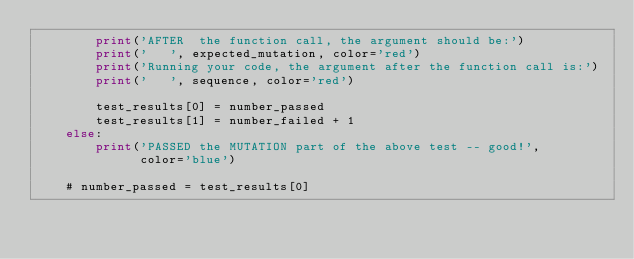Convert code to text. <code><loc_0><loc_0><loc_500><loc_500><_Python_>        print('AFTER  the function call, the argument should be:')
        print('   ', expected_mutation, color='red')
        print('Running your code, the argument after the function call is:')
        print('   ', sequence, color='red')

        test_results[0] = number_passed
        test_results[1] = number_failed + 1
    else:
        print('PASSED the MUTATION part of the above test -- good!',
              color='blue')

    # number_passed = test_results[0]</code> 